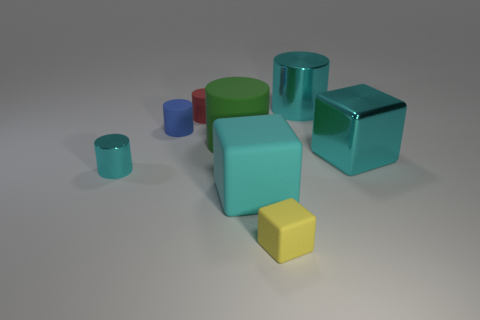Subtract 1 cylinders. How many cylinders are left? 4 Subtract all red cylinders. How many cylinders are left? 4 Subtract all small red cylinders. How many cylinders are left? 4 Subtract all green cylinders. Subtract all yellow cubes. How many cylinders are left? 4 Add 1 small brown shiny cylinders. How many objects exist? 9 Subtract all blocks. How many objects are left? 5 Subtract all brown rubber balls. Subtract all small blue objects. How many objects are left? 7 Add 2 large matte blocks. How many large matte blocks are left? 3 Add 4 large green matte objects. How many large green matte objects exist? 5 Subtract 0 yellow cylinders. How many objects are left? 8 